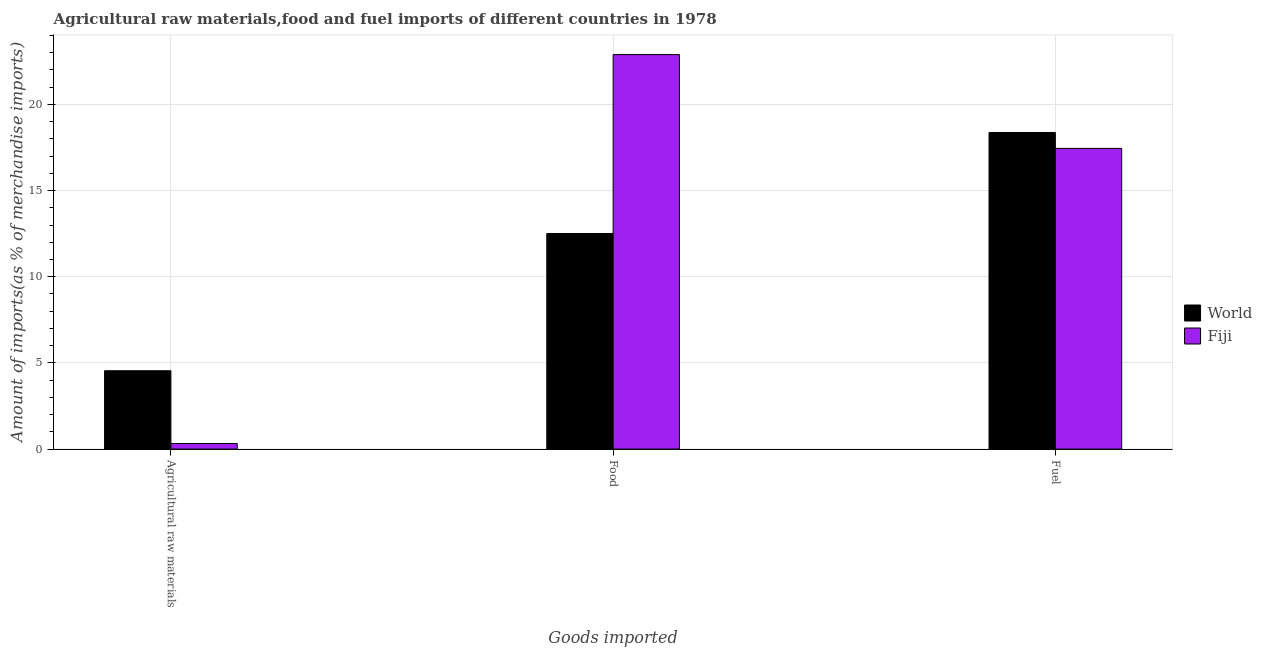Are the number of bars on each tick of the X-axis equal?
Provide a short and direct response. Yes. How many bars are there on the 3rd tick from the right?
Give a very brief answer. 2. What is the label of the 2nd group of bars from the left?
Ensure brevity in your answer.  Food. What is the percentage of raw materials imports in Fiji?
Your response must be concise. 0.32. Across all countries, what is the maximum percentage of raw materials imports?
Offer a very short reply. 4.55. Across all countries, what is the minimum percentage of raw materials imports?
Your answer should be very brief. 0.32. In which country was the percentage of food imports maximum?
Offer a very short reply. Fiji. In which country was the percentage of raw materials imports minimum?
Ensure brevity in your answer.  Fiji. What is the total percentage of food imports in the graph?
Provide a short and direct response. 35.4. What is the difference between the percentage of food imports in Fiji and that in World?
Provide a succinct answer. 10.38. What is the difference between the percentage of fuel imports in Fiji and the percentage of raw materials imports in World?
Provide a short and direct response. 12.9. What is the average percentage of raw materials imports per country?
Your answer should be compact. 2.43. What is the difference between the percentage of food imports and percentage of fuel imports in World?
Keep it short and to the point. -5.86. What is the ratio of the percentage of raw materials imports in Fiji to that in World?
Keep it short and to the point. 0.07. Is the difference between the percentage of fuel imports in Fiji and World greater than the difference between the percentage of raw materials imports in Fiji and World?
Offer a terse response. Yes. What is the difference between the highest and the second highest percentage of fuel imports?
Give a very brief answer. 0.92. What is the difference between the highest and the lowest percentage of fuel imports?
Provide a short and direct response. 0.92. What does the 2nd bar from the left in Agricultural raw materials represents?
Give a very brief answer. Fiji. What does the 1st bar from the right in Food represents?
Provide a succinct answer. Fiji. Is it the case that in every country, the sum of the percentage of raw materials imports and percentage of food imports is greater than the percentage of fuel imports?
Provide a succinct answer. No. How many bars are there?
Offer a terse response. 6. What is the difference between two consecutive major ticks on the Y-axis?
Provide a short and direct response. 5. Are the values on the major ticks of Y-axis written in scientific E-notation?
Ensure brevity in your answer.  No. Does the graph contain any zero values?
Your response must be concise. No. Does the graph contain grids?
Make the answer very short. Yes. Where does the legend appear in the graph?
Make the answer very short. Center right. How many legend labels are there?
Your response must be concise. 2. How are the legend labels stacked?
Offer a terse response. Vertical. What is the title of the graph?
Provide a succinct answer. Agricultural raw materials,food and fuel imports of different countries in 1978. What is the label or title of the X-axis?
Ensure brevity in your answer.  Goods imported. What is the label or title of the Y-axis?
Your answer should be very brief. Amount of imports(as % of merchandise imports). What is the Amount of imports(as % of merchandise imports) in World in Agricultural raw materials?
Give a very brief answer. 4.55. What is the Amount of imports(as % of merchandise imports) of Fiji in Agricultural raw materials?
Ensure brevity in your answer.  0.32. What is the Amount of imports(as % of merchandise imports) of World in Food?
Your answer should be compact. 12.51. What is the Amount of imports(as % of merchandise imports) of Fiji in Food?
Your answer should be compact. 22.89. What is the Amount of imports(as % of merchandise imports) of World in Fuel?
Provide a short and direct response. 18.37. What is the Amount of imports(as % of merchandise imports) of Fiji in Fuel?
Offer a very short reply. 17.45. Across all Goods imported, what is the maximum Amount of imports(as % of merchandise imports) in World?
Ensure brevity in your answer.  18.37. Across all Goods imported, what is the maximum Amount of imports(as % of merchandise imports) of Fiji?
Give a very brief answer. 22.89. Across all Goods imported, what is the minimum Amount of imports(as % of merchandise imports) of World?
Make the answer very short. 4.55. Across all Goods imported, what is the minimum Amount of imports(as % of merchandise imports) in Fiji?
Ensure brevity in your answer.  0.32. What is the total Amount of imports(as % of merchandise imports) of World in the graph?
Provide a short and direct response. 35.42. What is the total Amount of imports(as % of merchandise imports) of Fiji in the graph?
Your answer should be compact. 40.66. What is the difference between the Amount of imports(as % of merchandise imports) of World in Agricultural raw materials and that in Food?
Provide a succinct answer. -7.96. What is the difference between the Amount of imports(as % of merchandise imports) in Fiji in Agricultural raw materials and that in Food?
Your answer should be compact. -22.57. What is the difference between the Amount of imports(as % of merchandise imports) of World in Agricultural raw materials and that in Fuel?
Offer a very short reply. -13.83. What is the difference between the Amount of imports(as % of merchandise imports) in Fiji in Agricultural raw materials and that in Fuel?
Offer a very short reply. -17.12. What is the difference between the Amount of imports(as % of merchandise imports) in World in Food and that in Fuel?
Make the answer very short. -5.86. What is the difference between the Amount of imports(as % of merchandise imports) of Fiji in Food and that in Fuel?
Provide a short and direct response. 5.44. What is the difference between the Amount of imports(as % of merchandise imports) of World in Agricultural raw materials and the Amount of imports(as % of merchandise imports) of Fiji in Food?
Offer a terse response. -18.34. What is the difference between the Amount of imports(as % of merchandise imports) in World in Agricultural raw materials and the Amount of imports(as % of merchandise imports) in Fiji in Fuel?
Give a very brief answer. -12.9. What is the difference between the Amount of imports(as % of merchandise imports) of World in Food and the Amount of imports(as % of merchandise imports) of Fiji in Fuel?
Keep it short and to the point. -4.94. What is the average Amount of imports(as % of merchandise imports) of World per Goods imported?
Provide a succinct answer. 11.81. What is the average Amount of imports(as % of merchandise imports) in Fiji per Goods imported?
Make the answer very short. 13.55. What is the difference between the Amount of imports(as % of merchandise imports) in World and Amount of imports(as % of merchandise imports) in Fiji in Agricultural raw materials?
Ensure brevity in your answer.  4.22. What is the difference between the Amount of imports(as % of merchandise imports) of World and Amount of imports(as % of merchandise imports) of Fiji in Food?
Your answer should be compact. -10.38. What is the difference between the Amount of imports(as % of merchandise imports) in World and Amount of imports(as % of merchandise imports) in Fiji in Fuel?
Ensure brevity in your answer.  0.92. What is the ratio of the Amount of imports(as % of merchandise imports) in World in Agricultural raw materials to that in Food?
Make the answer very short. 0.36. What is the ratio of the Amount of imports(as % of merchandise imports) of Fiji in Agricultural raw materials to that in Food?
Your response must be concise. 0.01. What is the ratio of the Amount of imports(as % of merchandise imports) in World in Agricultural raw materials to that in Fuel?
Keep it short and to the point. 0.25. What is the ratio of the Amount of imports(as % of merchandise imports) of Fiji in Agricultural raw materials to that in Fuel?
Your answer should be very brief. 0.02. What is the ratio of the Amount of imports(as % of merchandise imports) in World in Food to that in Fuel?
Ensure brevity in your answer.  0.68. What is the ratio of the Amount of imports(as % of merchandise imports) in Fiji in Food to that in Fuel?
Keep it short and to the point. 1.31. What is the difference between the highest and the second highest Amount of imports(as % of merchandise imports) in World?
Ensure brevity in your answer.  5.86. What is the difference between the highest and the second highest Amount of imports(as % of merchandise imports) in Fiji?
Your response must be concise. 5.44. What is the difference between the highest and the lowest Amount of imports(as % of merchandise imports) of World?
Your response must be concise. 13.83. What is the difference between the highest and the lowest Amount of imports(as % of merchandise imports) of Fiji?
Make the answer very short. 22.57. 